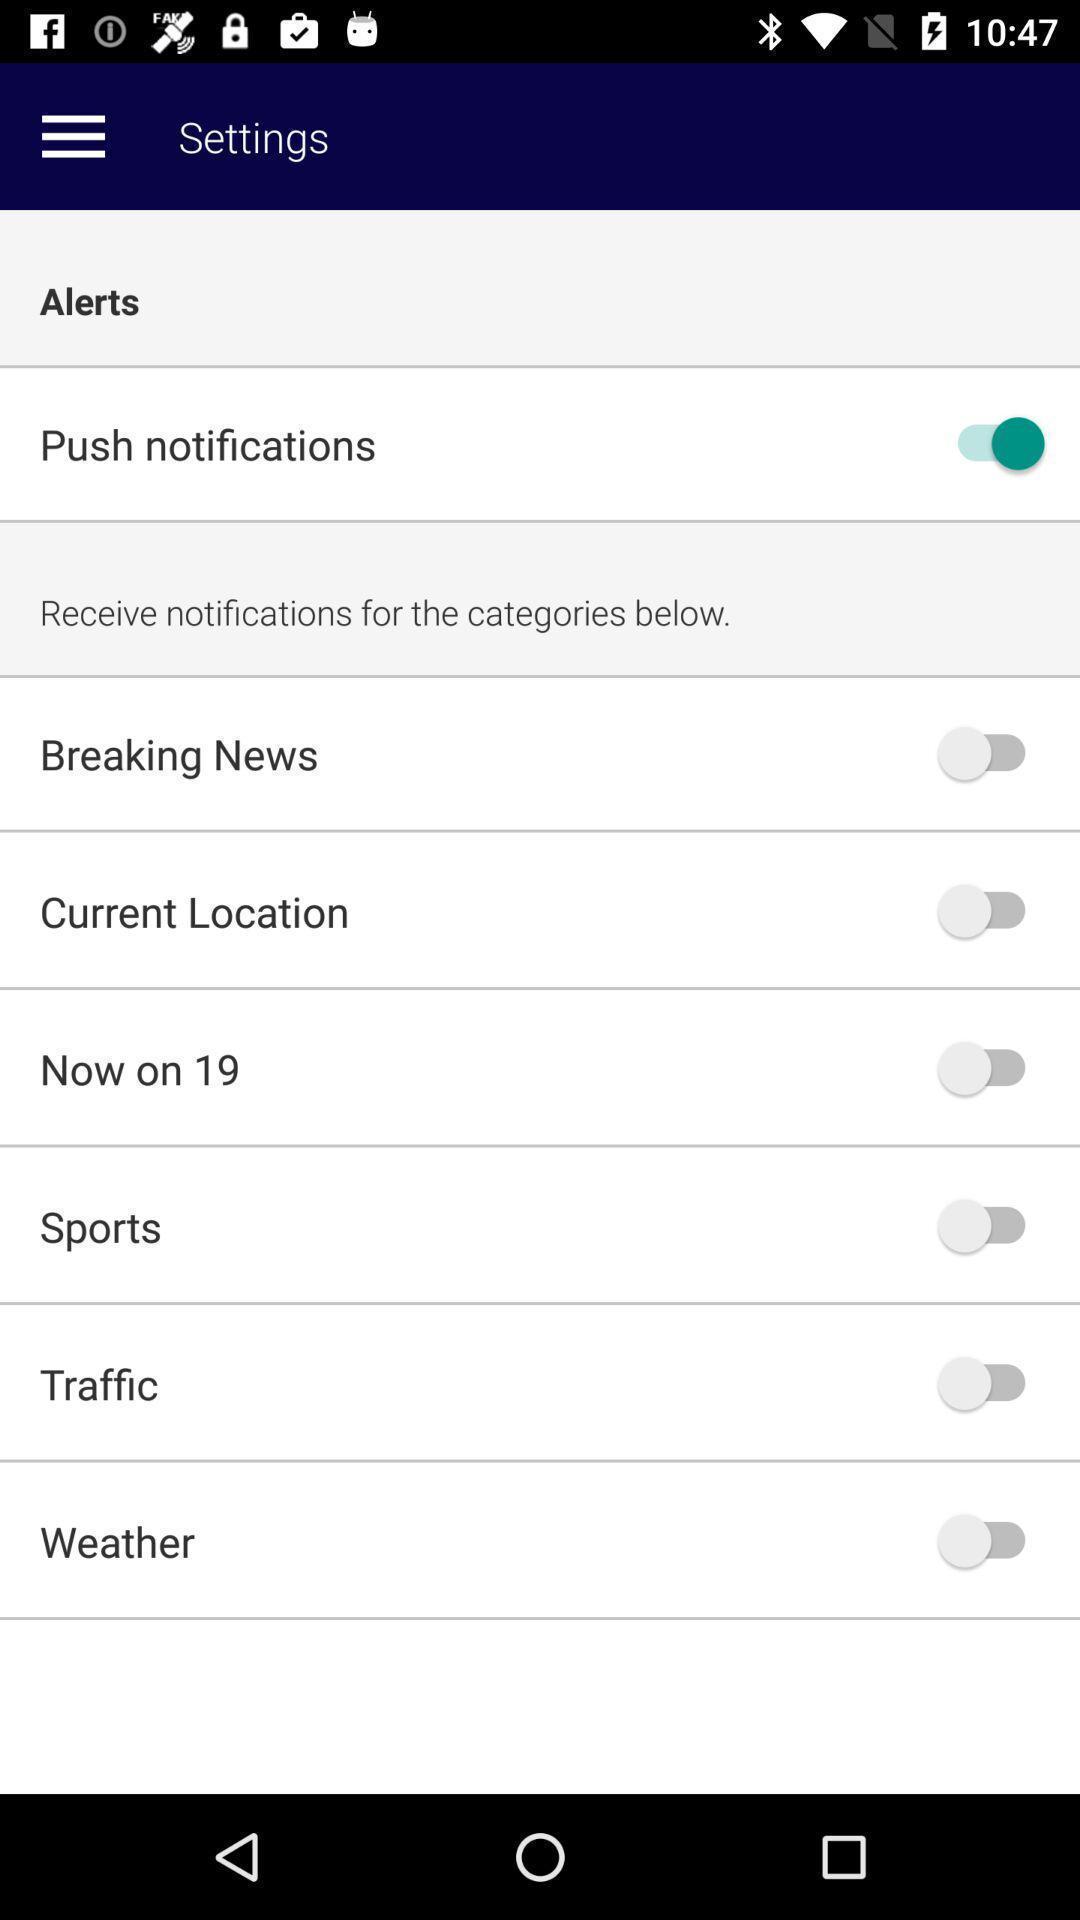Give me a summary of this screen capture. Setting page displaying the various options. 